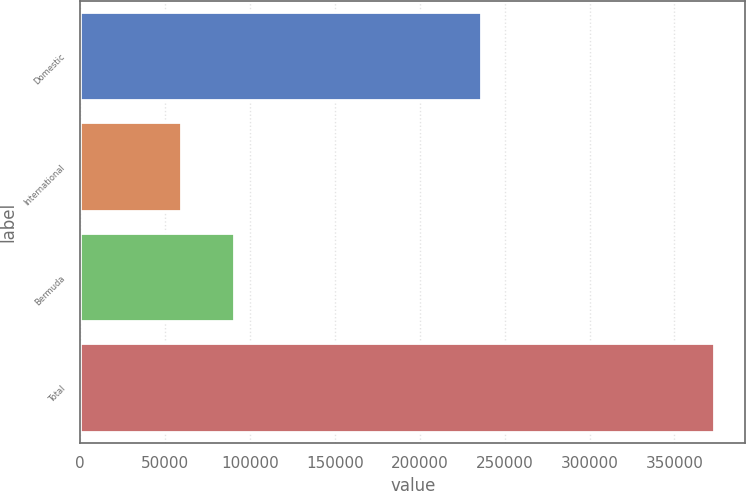Convert chart to OTSL. <chart><loc_0><loc_0><loc_500><loc_500><bar_chart><fcel>Domestic<fcel>International<fcel>Bermuda<fcel>Total<nl><fcel>235956<fcel>59322<fcel>90697<fcel>373072<nl></chart> 